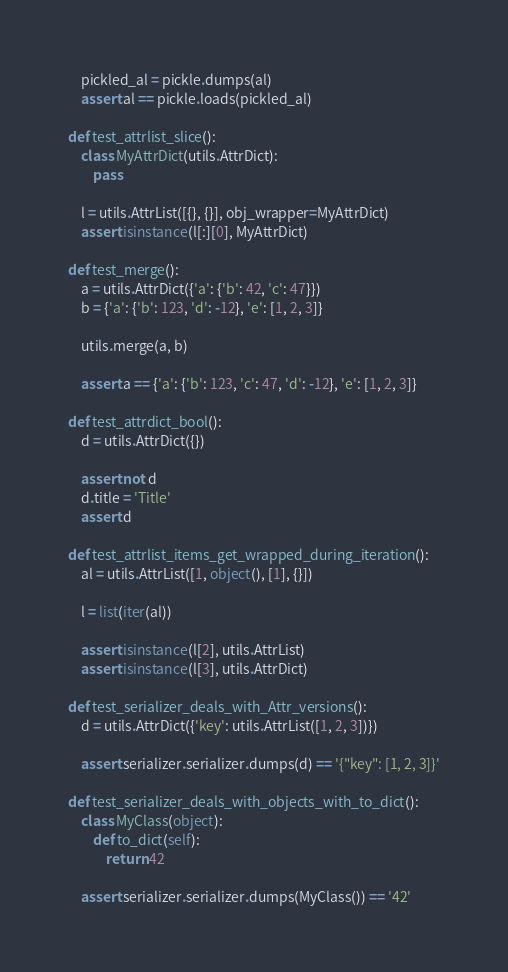Convert code to text. <code><loc_0><loc_0><loc_500><loc_500><_Python_>    pickled_al = pickle.dumps(al)
    assert al == pickle.loads(pickled_al)

def test_attrlist_slice():
    class MyAttrDict(utils.AttrDict):
        pass

    l = utils.AttrList([{}, {}], obj_wrapper=MyAttrDict)
    assert isinstance(l[:][0], MyAttrDict)

def test_merge():
    a = utils.AttrDict({'a': {'b': 42, 'c': 47}})
    b = {'a': {'b': 123, 'd': -12}, 'e': [1, 2, 3]}

    utils.merge(a, b)

    assert a == {'a': {'b': 123, 'c': 47, 'd': -12}, 'e': [1, 2, 3]}

def test_attrdict_bool():
    d = utils.AttrDict({})

    assert not d
    d.title = 'Title'
    assert d

def test_attrlist_items_get_wrapped_during_iteration():
    al = utils.AttrList([1, object(), [1], {}])

    l = list(iter(al))

    assert isinstance(l[2], utils.AttrList)
    assert isinstance(l[3], utils.AttrDict)

def test_serializer_deals_with_Attr_versions():
    d = utils.AttrDict({'key': utils.AttrList([1, 2, 3])})

    assert serializer.serializer.dumps(d) == '{"key": [1, 2, 3]}'

def test_serializer_deals_with_objects_with_to_dict():
    class MyClass(object):
        def to_dict(self):
            return 42

    assert serializer.serializer.dumps(MyClass()) == '42'
</code> 